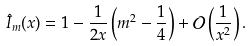<formula> <loc_0><loc_0><loc_500><loc_500>\hat { I } _ { m } ( x ) = 1 - \frac { 1 } { 2 x } \left ( m ^ { 2 } - \frac { 1 } { 4 } \right ) + \mathcal { O } \left ( \frac { 1 } { x ^ { 2 } } \right ) .</formula> 